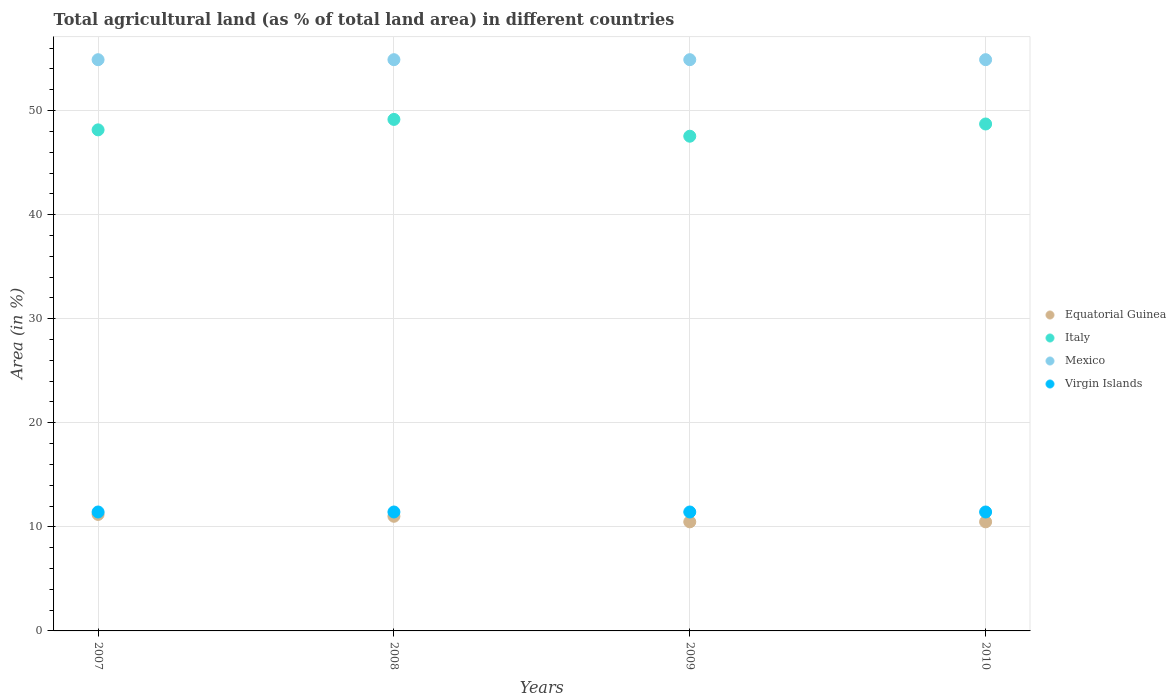How many different coloured dotlines are there?
Keep it short and to the point. 4. Is the number of dotlines equal to the number of legend labels?
Offer a very short reply. Yes. What is the percentage of agricultural land in Italy in 2009?
Offer a terse response. 47.54. Across all years, what is the maximum percentage of agricultural land in Italy?
Offer a very short reply. 49.15. Across all years, what is the minimum percentage of agricultural land in Equatorial Guinea?
Your answer should be very brief. 10.48. In which year was the percentage of agricultural land in Mexico minimum?
Your response must be concise. 2007. What is the total percentage of agricultural land in Mexico in the graph?
Keep it short and to the point. 219.56. What is the difference between the percentage of agricultural land in Virgin Islands in 2010 and the percentage of agricultural land in Equatorial Guinea in 2007?
Provide a short and direct response. 0.23. What is the average percentage of agricultural land in Virgin Islands per year?
Give a very brief answer. 11.43. In the year 2007, what is the difference between the percentage of agricultural land in Mexico and percentage of agricultural land in Virgin Islands?
Offer a very short reply. 43.46. In how many years, is the percentage of agricultural land in Mexico greater than 38 %?
Make the answer very short. 4. What is the ratio of the percentage of agricultural land in Virgin Islands in 2007 to that in 2008?
Provide a succinct answer. 1. What is the difference between the highest and the lowest percentage of agricultural land in Equatorial Guinea?
Keep it short and to the point. 0.71. Does the percentage of agricultural land in Equatorial Guinea monotonically increase over the years?
Your response must be concise. No. Is the percentage of agricultural land in Italy strictly less than the percentage of agricultural land in Virgin Islands over the years?
Keep it short and to the point. No. How many dotlines are there?
Your response must be concise. 4. Where does the legend appear in the graph?
Offer a very short reply. Center right. What is the title of the graph?
Your response must be concise. Total agricultural land (as % of total land area) in different countries. What is the label or title of the Y-axis?
Provide a short and direct response. Area (in %). What is the Area (in %) in Equatorial Guinea in 2007?
Your response must be concise. 11.19. What is the Area (in %) of Italy in 2007?
Offer a very short reply. 48.15. What is the Area (in %) in Mexico in 2007?
Give a very brief answer. 54.89. What is the Area (in %) in Virgin Islands in 2007?
Offer a very short reply. 11.43. What is the Area (in %) of Equatorial Guinea in 2008?
Provide a short and direct response. 11.02. What is the Area (in %) in Italy in 2008?
Your answer should be very brief. 49.15. What is the Area (in %) of Mexico in 2008?
Ensure brevity in your answer.  54.89. What is the Area (in %) of Virgin Islands in 2008?
Your answer should be compact. 11.43. What is the Area (in %) of Equatorial Guinea in 2009?
Make the answer very short. 10.48. What is the Area (in %) in Italy in 2009?
Ensure brevity in your answer.  47.54. What is the Area (in %) of Mexico in 2009?
Offer a very short reply. 54.89. What is the Area (in %) of Virgin Islands in 2009?
Give a very brief answer. 11.43. What is the Area (in %) of Equatorial Guinea in 2010?
Your response must be concise. 10.48. What is the Area (in %) in Italy in 2010?
Provide a succinct answer. 48.71. What is the Area (in %) in Mexico in 2010?
Offer a very short reply. 54.89. What is the Area (in %) in Virgin Islands in 2010?
Ensure brevity in your answer.  11.43. Across all years, what is the maximum Area (in %) in Equatorial Guinea?
Offer a very short reply. 11.19. Across all years, what is the maximum Area (in %) in Italy?
Offer a terse response. 49.15. Across all years, what is the maximum Area (in %) in Mexico?
Your response must be concise. 54.89. Across all years, what is the maximum Area (in %) in Virgin Islands?
Provide a short and direct response. 11.43. Across all years, what is the minimum Area (in %) of Equatorial Guinea?
Give a very brief answer. 10.48. Across all years, what is the minimum Area (in %) of Italy?
Make the answer very short. 47.54. Across all years, what is the minimum Area (in %) of Mexico?
Ensure brevity in your answer.  54.89. Across all years, what is the minimum Area (in %) of Virgin Islands?
Provide a succinct answer. 11.43. What is the total Area (in %) in Equatorial Guinea in the graph?
Your answer should be compact. 43.17. What is the total Area (in %) of Italy in the graph?
Your answer should be very brief. 193.55. What is the total Area (in %) in Mexico in the graph?
Provide a short and direct response. 219.56. What is the total Area (in %) in Virgin Islands in the graph?
Your answer should be very brief. 45.71. What is the difference between the Area (in %) in Equatorial Guinea in 2007 and that in 2008?
Offer a terse response. 0.18. What is the difference between the Area (in %) of Italy in 2007 and that in 2008?
Make the answer very short. -1. What is the difference between the Area (in %) of Mexico in 2007 and that in 2008?
Your answer should be very brief. -0. What is the difference between the Area (in %) in Equatorial Guinea in 2007 and that in 2009?
Provide a succinct answer. 0.71. What is the difference between the Area (in %) of Italy in 2007 and that in 2009?
Offer a terse response. 0.61. What is the difference between the Area (in %) of Mexico in 2007 and that in 2009?
Your answer should be very brief. -0. What is the difference between the Area (in %) of Virgin Islands in 2007 and that in 2009?
Offer a terse response. 0. What is the difference between the Area (in %) in Equatorial Guinea in 2007 and that in 2010?
Give a very brief answer. 0.71. What is the difference between the Area (in %) in Italy in 2007 and that in 2010?
Provide a succinct answer. -0.56. What is the difference between the Area (in %) of Mexico in 2007 and that in 2010?
Provide a succinct answer. -0. What is the difference between the Area (in %) of Virgin Islands in 2007 and that in 2010?
Provide a succinct answer. 0. What is the difference between the Area (in %) in Equatorial Guinea in 2008 and that in 2009?
Provide a succinct answer. 0.53. What is the difference between the Area (in %) in Italy in 2008 and that in 2009?
Your answer should be compact. 1.61. What is the difference between the Area (in %) in Mexico in 2008 and that in 2009?
Provide a short and direct response. 0. What is the difference between the Area (in %) in Equatorial Guinea in 2008 and that in 2010?
Your answer should be very brief. 0.53. What is the difference between the Area (in %) of Italy in 2008 and that in 2010?
Offer a very short reply. 0.44. What is the difference between the Area (in %) in Virgin Islands in 2008 and that in 2010?
Offer a terse response. 0. What is the difference between the Area (in %) of Equatorial Guinea in 2009 and that in 2010?
Offer a very short reply. 0. What is the difference between the Area (in %) of Italy in 2009 and that in 2010?
Give a very brief answer. -1.17. What is the difference between the Area (in %) in Mexico in 2009 and that in 2010?
Your response must be concise. 0. What is the difference between the Area (in %) of Virgin Islands in 2009 and that in 2010?
Give a very brief answer. 0. What is the difference between the Area (in %) in Equatorial Guinea in 2007 and the Area (in %) in Italy in 2008?
Make the answer very short. -37.96. What is the difference between the Area (in %) in Equatorial Guinea in 2007 and the Area (in %) in Mexico in 2008?
Give a very brief answer. -43.7. What is the difference between the Area (in %) of Equatorial Guinea in 2007 and the Area (in %) of Virgin Islands in 2008?
Give a very brief answer. -0.23. What is the difference between the Area (in %) of Italy in 2007 and the Area (in %) of Mexico in 2008?
Your answer should be very brief. -6.74. What is the difference between the Area (in %) in Italy in 2007 and the Area (in %) in Virgin Islands in 2008?
Provide a short and direct response. 36.72. What is the difference between the Area (in %) of Mexico in 2007 and the Area (in %) of Virgin Islands in 2008?
Offer a terse response. 43.46. What is the difference between the Area (in %) of Equatorial Guinea in 2007 and the Area (in %) of Italy in 2009?
Your answer should be very brief. -36.34. What is the difference between the Area (in %) of Equatorial Guinea in 2007 and the Area (in %) of Mexico in 2009?
Make the answer very short. -43.7. What is the difference between the Area (in %) in Equatorial Guinea in 2007 and the Area (in %) in Virgin Islands in 2009?
Your answer should be very brief. -0.23. What is the difference between the Area (in %) of Italy in 2007 and the Area (in %) of Mexico in 2009?
Your answer should be very brief. -6.74. What is the difference between the Area (in %) in Italy in 2007 and the Area (in %) in Virgin Islands in 2009?
Offer a very short reply. 36.72. What is the difference between the Area (in %) of Mexico in 2007 and the Area (in %) of Virgin Islands in 2009?
Offer a very short reply. 43.46. What is the difference between the Area (in %) in Equatorial Guinea in 2007 and the Area (in %) in Italy in 2010?
Offer a terse response. -37.52. What is the difference between the Area (in %) in Equatorial Guinea in 2007 and the Area (in %) in Mexico in 2010?
Your answer should be very brief. -43.7. What is the difference between the Area (in %) in Equatorial Guinea in 2007 and the Area (in %) in Virgin Islands in 2010?
Offer a terse response. -0.23. What is the difference between the Area (in %) in Italy in 2007 and the Area (in %) in Mexico in 2010?
Offer a very short reply. -6.74. What is the difference between the Area (in %) of Italy in 2007 and the Area (in %) of Virgin Islands in 2010?
Offer a very short reply. 36.72. What is the difference between the Area (in %) of Mexico in 2007 and the Area (in %) of Virgin Islands in 2010?
Give a very brief answer. 43.46. What is the difference between the Area (in %) in Equatorial Guinea in 2008 and the Area (in %) in Italy in 2009?
Your response must be concise. -36.52. What is the difference between the Area (in %) of Equatorial Guinea in 2008 and the Area (in %) of Mexico in 2009?
Give a very brief answer. -43.87. What is the difference between the Area (in %) in Equatorial Guinea in 2008 and the Area (in %) in Virgin Islands in 2009?
Keep it short and to the point. -0.41. What is the difference between the Area (in %) of Italy in 2008 and the Area (in %) of Mexico in 2009?
Offer a very short reply. -5.74. What is the difference between the Area (in %) of Italy in 2008 and the Area (in %) of Virgin Islands in 2009?
Make the answer very short. 37.72. What is the difference between the Area (in %) in Mexico in 2008 and the Area (in %) in Virgin Islands in 2009?
Your answer should be very brief. 43.46. What is the difference between the Area (in %) in Equatorial Guinea in 2008 and the Area (in %) in Italy in 2010?
Your answer should be compact. -37.69. What is the difference between the Area (in %) in Equatorial Guinea in 2008 and the Area (in %) in Mexico in 2010?
Offer a very short reply. -43.87. What is the difference between the Area (in %) in Equatorial Guinea in 2008 and the Area (in %) in Virgin Islands in 2010?
Offer a terse response. -0.41. What is the difference between the Area (in %) of Italy in 2008 and the Area (in %) of Mexico in 2010?
Keep it short and to the point. -5.74. What is the difference between the Area (in %) of Italy in 2008 and the Area (in %) of Virgin Islands in 2010?
Your answer should be compact. 37.72. What is the difference between the Area (in %) of Mexico in 2008 and the Area (in %) of Virgin Islands in 2010?
Give a very brief answer. 43.46. What is the difference between the Area (in %) in Equatorial Guinea in 2009 and the Area (in %) in Italy in 2010?
Give a very brief answer. -38.23. What is the difference between the Area (in %) of Equatorial Guinea in 2009 and the Area (in %) of Mexico in 2010?
Make the answer very short. -44.41. What is the difference between the Area (in %) of Equatorial Guinea in 2009 and the Area (in %) of Virgin Islands in 2010?
Your answer should be very brief. -0.95. What is the difference between the Area (in %) of Italy in 2009 and the Area (in %) of Mexico in 2010?
Your answer should be compact. -7.35. What is the difference between the Area (in %) in Italy in 2009 and the Area (in %) in Virgin Islands in 2010?
Your answer should be very brief. 36.11. What is the difference between the Area (in %) of Mexico in 2009 and the Area (in %) of Virgin Islands in 2010?
Provide a succinct answer. 43.46. What is the average Area (in %) in Equatorial Guinea per year?
Your answer should be compact. 10.79. What is the average Area (in %) of Italy per year?
Your answer should be very brief. 48.39. What is the average Area (in %) in Mexico per year?
Offer a terse response. 54.89. What is the average Area (in %) of Virgin Islands per year?
Your answer should be very brief. 11.43. In the year 2007, what is the difference between the Area (in %) of Equatorial Guinea and Area (in %) of Italy?
Offer a very short reply. -36.95. In the year 2007, what is the difference between the Area (in %) of Equatorial Guinea and Area (in %) of Mexico?
Your response must be concise. -43.69. In the year 2007, what is the difference between the Area (in %) in Equatorial Guinea and Area (in %) in Virgin Islands?
Your response must be concise. -0.23. In the year 2007, what is the difference between the Area (in %) in Italy and Area (in %) in Mexico?
Give a very brief answer. -6.74. In the year 2007, what is the difference between the Area (in %) in Italy and Area (in %) in Virgin Islands?
Keep it short and to the point. 36.72. In the year 2007, what is the difference between the Area (in %) in Mexico and Area (in %) in Virgin Islands?
Your answer should be compact. 43.46. In the year 2008, what is the difference between the Area (in %) of Equatorial Guinea and Area (in %) of Italy?
Give a very brief answer. -38.13. In the year 2008, what is the difference between the Area (in %) in Equatorial Guinea and Area (in %) in Mexico?
Provide a short and direct response. -43.87. In the year 2008, what is the difference between the Area (in %) in Equatorial Guinea and Area (in %) in Virgin Islands?
Make the answer very short. -0.41. In the year 2008, what is the difference between the Area (in %) of Italy and Area (in %) of Mexico?
Make the answer very short. -5.74. In the year 2008, what is the difference between the Area (in %) in Italy and Area (in %) in Virgin Islands?
Ensure brevity in your answer.  37.72. In the year 2008, what is the difference between the Area (in %) in Mexico and Area (in %) in Virgin Islands?
Your answer should be compact. 43.46. In the year 2009, what is the difference between the Area (in %) in Equatorial Guinea and Area (in %) in Italy?
Make the answer very short. -37.06. In the year 2009, what is the difference between the Area (in %) of Equatorial Guinea and Area (in %) of Mexico?
Offer a terse response. -44.41. In the year 2009, what is the difference between the Area (in %) in Equatorial Guinea and Area (in %) in Virgin Islands?
Give a very brief answer. -0.95. In the year 2009, what is the difference between the Area (in %) of Italy and Area (in %) of Mexico?
Provide a short and direct response. -7.35. In the year 2009, what is the difference between the Area (in %) of Italy and Area (in %) of Virgin Islands?
Give a very brief answer. 36.11. In the year 2009, what is the difference between the Area (in %) of Mexico and Area (in %) of Virgin Islands?
Provide a succinct answer. 43.46. In the year 2010, what is the difference between the Area (in %) in Equatorial Guinea and Area (in %) in Italy?
Keep it short and to the point. -38.23. In the year 2010, what is the difference between the Area (in %) in Equatorial Guinea and Area (in %) in Mexico?
Your response must be concise. -44.41. In the year 2010, what is the difference between the Area (in %) in Equatorial Guinea and Area (in %) in Virgin Islands?
Give a very brief answer. -0.95. In the year 2010, what is the difference between the Area (in %) of Italy and Area (in %) of Mexico?
Give a very brief answer. -6.18. In the year 2010, what is the difference between the Area (in %) of Italy and Area (in %) of Virgin Islands?
Keep it short and to the point. 37.28. In the year 2010, what is the difference between the Area (in %) of Mexico and Area (in %) of Virgin Islands?
Give a very brief answer. 43.46. What is the ratio of the Area (in %) in Equatorial Guinea in 2007 to that in 2008?
Ensure brevity in your answer.  1.02. What is the ratio of the Area (in %) of Italy in 2007 to that in 2008?
Provide a short and direct response. 0.98. What is the ratio of the Area (in %) in Equatorial Guinea in 2007 to that in 2009?
Your response must be concise. 1.07. What is the ratio of the Area (in %) in Italy in 2007 to that in 2009?
Your answer should be compact. 1.01. What is the ratio of the Area (in %) in Mexico in 2007 to that in 2009?
Your answer should be compact. 1. What is the ratio of the Area (in %) of Virgin Islands in 2007 to that in 2009?
Your answer should be very brief. 1. What is the ratio of the Area (in %) of Equatorial Guinea in 2007 to that in 2010?
Your answer should be very brief. 1.07. What is the ratio of the Area (in %) in Italy in 2007 to that in 2010?
Ensure brevity in your answer.  0.99. What is the ratio of the Area (in %) of Virgin Islands in 2007 to that in 2010?
Make the answer very short. 1. What is the ratio of the Area (in %) in Equatorial Guinea in 2008 to that in 2009?
Your response must be concise. 1.05. What is the ratio of the Area (in %) of Italy in 2008 to that in 2009?
Provide a short and direct response. 1.03. What is the ratio of the Area (in %) of Virgin Islands in 2008 to that in 2009?
Your response must be concise. 1. What is the ratio of the Area (in %) of Equatorial Guinea in 2008 to that in 2010?
Give a very brief answer. 1.05. What is the ratio of the Area (in %) in Italy in 2008 to that in 2010?
Ensure brevity in your answer.  1.01. What is the ratio of the Area (in %) of Virgin Islands in 2008 to that in 2010?
Your answer should be compact. 1. What is the ratio of the Area (in %) in Equatorial Guinea in 2009 to that in 2010?
Ensure brevity in your answer.  1. What is the ratio of the Area (in %) of Italy in 2009 to that in 2010?
Make the answer very short. 0.98. What is the ratio of the Area (in %) in Virgin Islands in 2009 to that in 2010?
Offer a very short reply. 1. What is the difference between the highest and the second highest Area (in %) of Equatorial Guinea?
Offer a terse response. 0.18. What is the difference between the highest and the second highest Area (in %) in Italy?
Provide a succinct answer. 0.44. What is the difference between the highest and the second highest Area (in %) of Virgin Islands?
Ensure brevity in your answer.  0. What is the difference between the highest and the lowest Area (in %) of Equatorial Guinea?
Your response must be concise. 0.71. What is the difference between the highest and the lowest Area (in %) in Italy?
Offer a terse response. 1.61. What is the difference between the highest and the lowest Area (in %) of Mexico?
Make the answer very short. 0. 